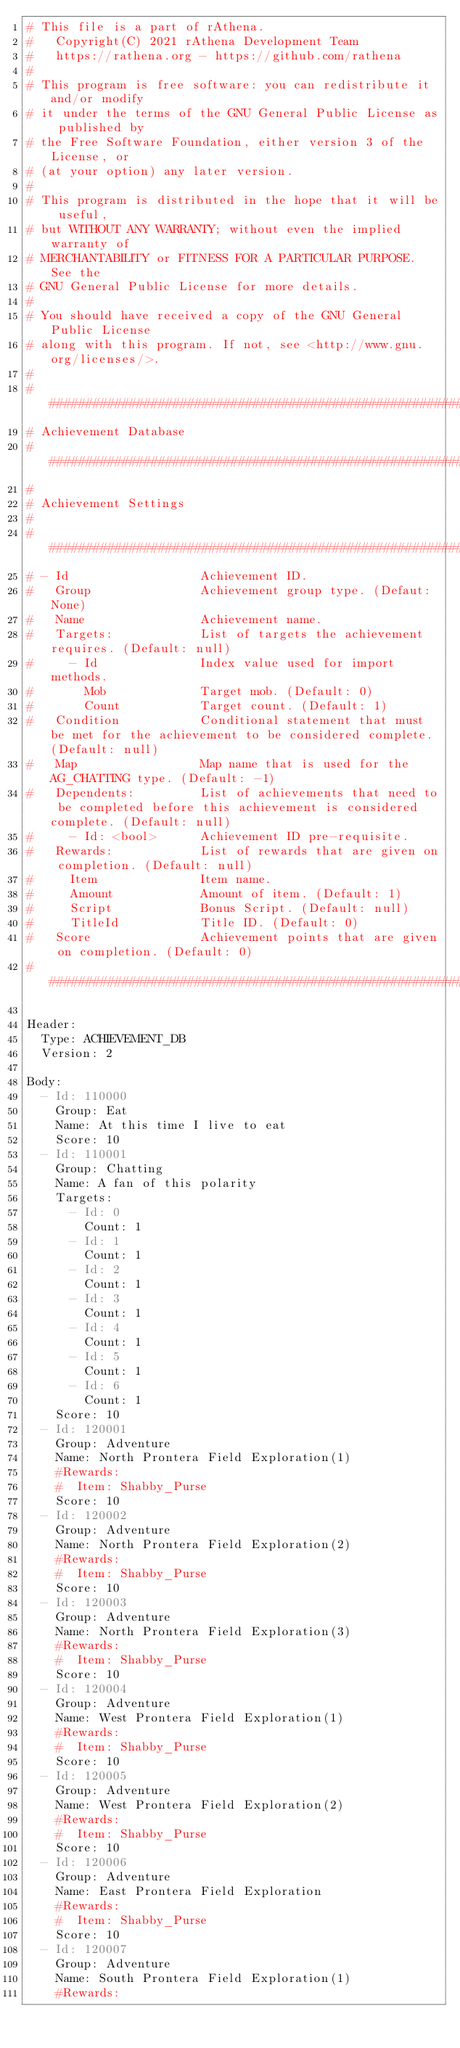Convert code to text. <code><loc_0><loc_0><loc_500><loc_500><_YAML_># This file is a part of rAthena.
#   Copyright(C) 2021 rAthena Development Team
#   https://rathena.org - https://github.com/rathena
#
# This program is free software: you can redistribute it and/or modify
# it under the terms of the GNU General Public License as published by
# the Free Software Foundation, either version 3 of the License, or
# (at your option) any later version.
#
# This program is distributed in the hope that it will be useful,
# but WITHOUT ANY WARRANTY; without even the implied warranty of
# MERCHANTABILITY or FITNESS FOR A PARTICULAR PURPOSE. See the
# GNU General Public License for more details.
#
# You should have received a copy of the GNU General Public License
# along with this program. If not, see <http://www.gnu.org/licenses/>.
#
###########################################################################
# Achievement Database
###########################################################################
#
# Achievement Settings
#
###########################################################################
# - Id                  Achievement ID.
#   Group               Achievement group type. (Defaut: None)
#   Name                Achievement name.
#   Targets:            List of targets the achievement requires. (Default: null)
#     - Id              Index value used for import methods.
#       Mob             Target mob. (Default: 0)
#       Count           Target count. (Default: 1)
#   Condition           Conditional statement that must be met for the achievement to be considered complete. (Default: null)
#   Map                 Map name that is used for the AG_CHATTING type. (Default: -1)
#   Dependents:         List of achievements that need to be completed before this achievement is considered complete. (Default: null)
#     - Id: <bool>      Achievement ID pre-requisite.
#   Rewards:            List of rewards that are given on completion. (Default: null)
#     Item              Item name.
#     Amount            Amount of item. (Default: 1)
#     Script            Bonus Script. (Default: null)
#     TitleId           Title ID. (Default: 0)
#   Score               Achievement points that are given on completion. (Default: 0)
###########################################################################

Header:
  Type: ACHIEVEMENT_DB
  Version: 2

Body:
  - Id: 110000
    Group: Eat
    Name: At this time I live to eat
    Score: 10
  - Id: 110001
    Group: Chatting
    Name: A fan of this polarity
    Targets:
      - Id: 0
        Count: 1
      - Id: 1
        Count: 1
      - Id: 2
        Count: 1
      - Id: 3
        Count: 1
      - Id: 4
        Count: 1
      - Id: 5
        Count: 1
      - Id: 6
        Count: 1
    Score: 10
  - Id: 120001
    Group: Adventure
    Name: North Prontera Field Exploration(1)
    #Rewards:
    #  Item: Shabby_Purse
    Score: 10
  - Id: 120002
    Group: Adventure
    Name: North Prontera Field Exploration(2)
    #Rewards:
    #  Item: Shabby_Purse
    Score: 10
  - Id: 120003
    Group: Adventure
    Name: North Prontera Field Exploration(3)
    #Rewards:
    #  Item: Shabby_Purse
    Score: 10
  - Id: 120004
    Group: Adventure
    Name: West Prontera Field Exploration(1)
    #Rewards:
    #  Item: Shabby_Purse
    Score: 10
  - Id: 120005
    Group: Adventure
    Name: West Prontera Field Exploration(2)
    #Rewards:
    #  Item: Shabby_Purse
    Score: 10
  - Id: 120006
    Group: Adventure
    Name: East Prontera Field Exploration
    #Rewards:
    #  Item: Shabby_Purse
    Score: 10
  - Id: 120007
    Group: Adventure
    Name: South Prontera Field Exploration(1)
    #Rewards:</code> 